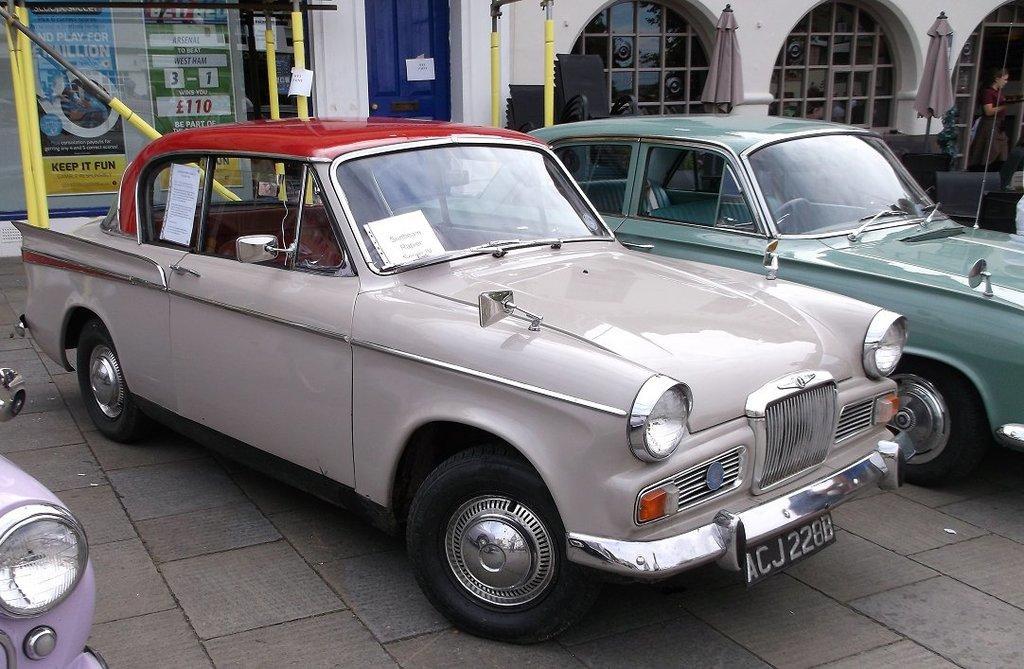Could you give a brief overview of what you see in this image? In the picture we can see two vintage cars are parked on the floor one is light gray in color and one is green in color and beside it, we can see a part of another car with a headlight and behind the cars we can see a building wall with glass windows and some poles near it and a door which is blue in color. 